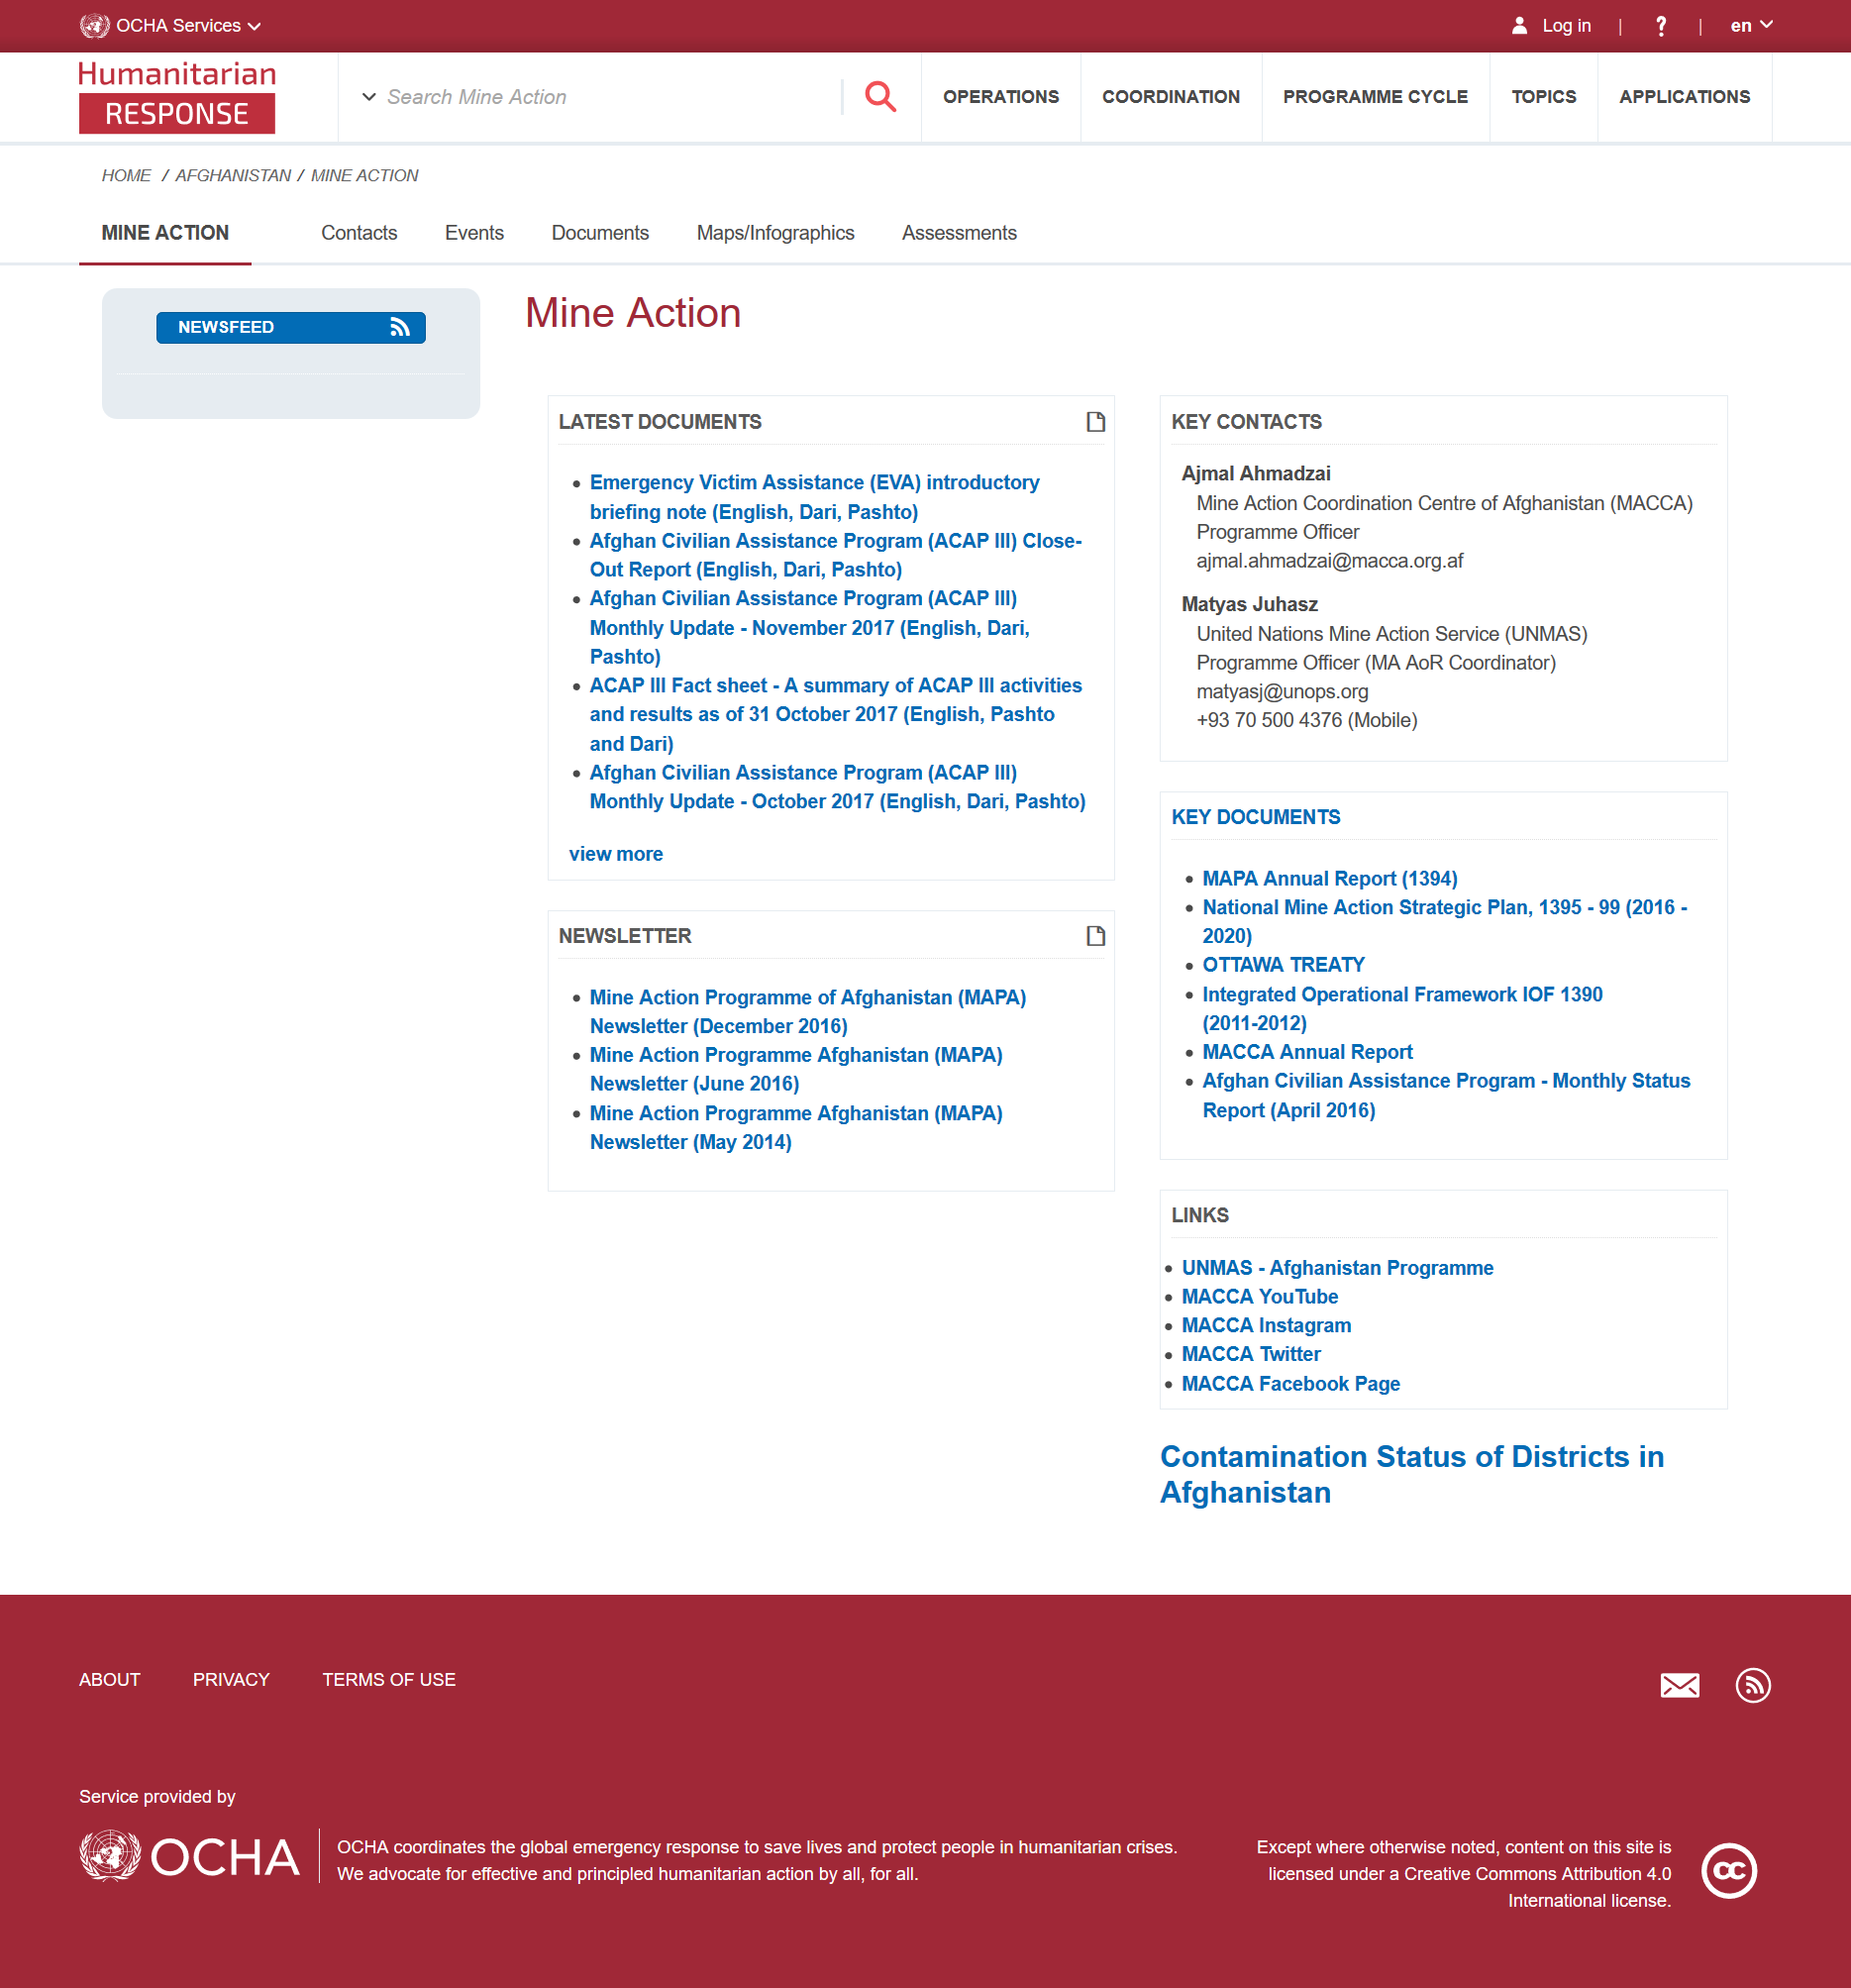Point out several critical features in this image. Emergency Victim Assistance, commonly known as EVA, is a service that provides support and assistance to individuals in the event of an emergency. The page is concerned with Mine Action. There are a total of 5 documents in the 'latest documents' section. 